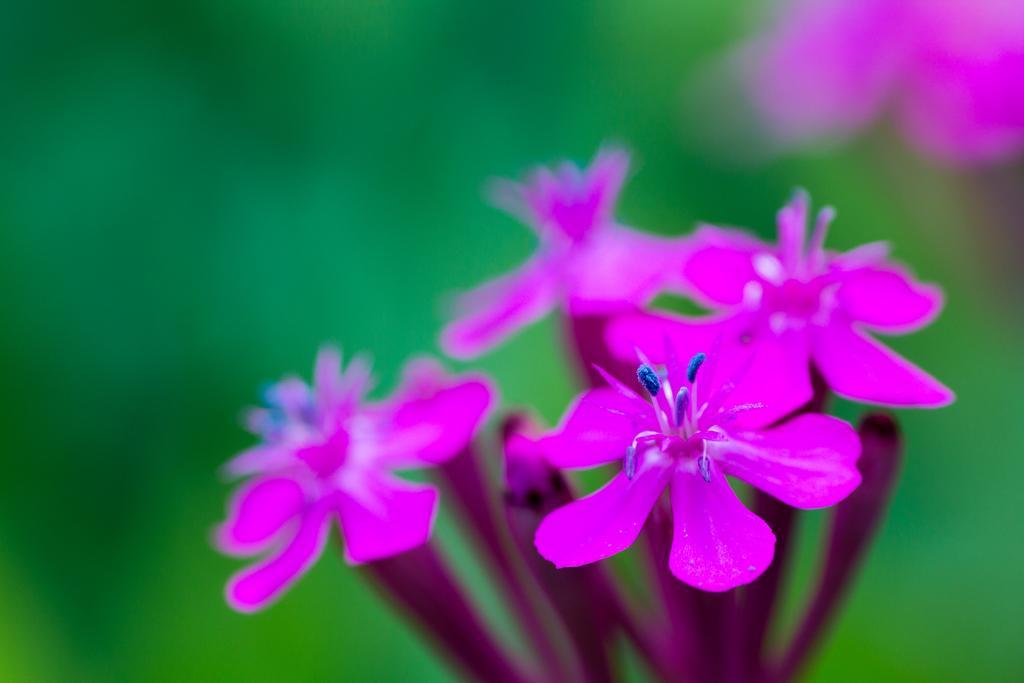Describe this image in one or two sentences. In this image I can see flowers in purple color and the background is in green color. 